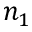Convert formula to latex. <formula><loc_0><loc_0><loc_500><loc_500>n _ { 1 }</formula> 